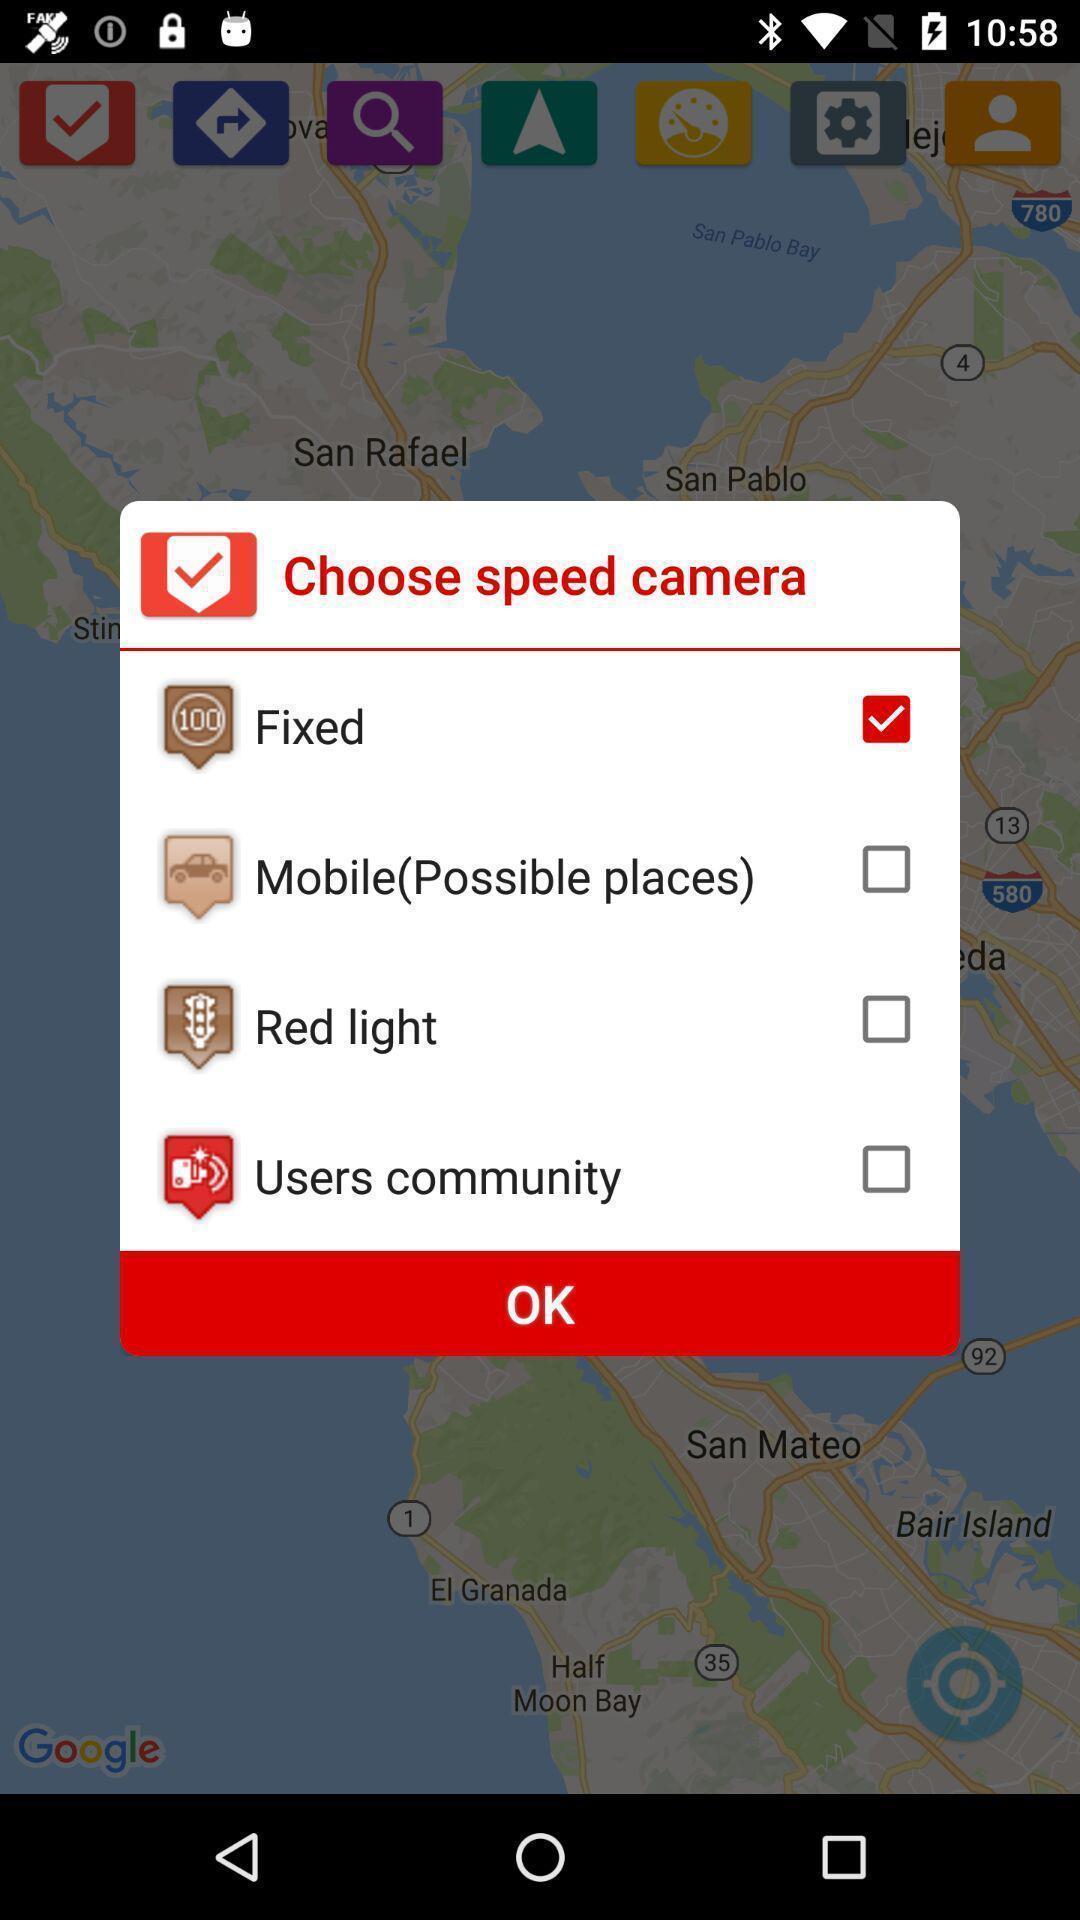Please provide a description for this image. Pop-up with options in a navigation based app. 